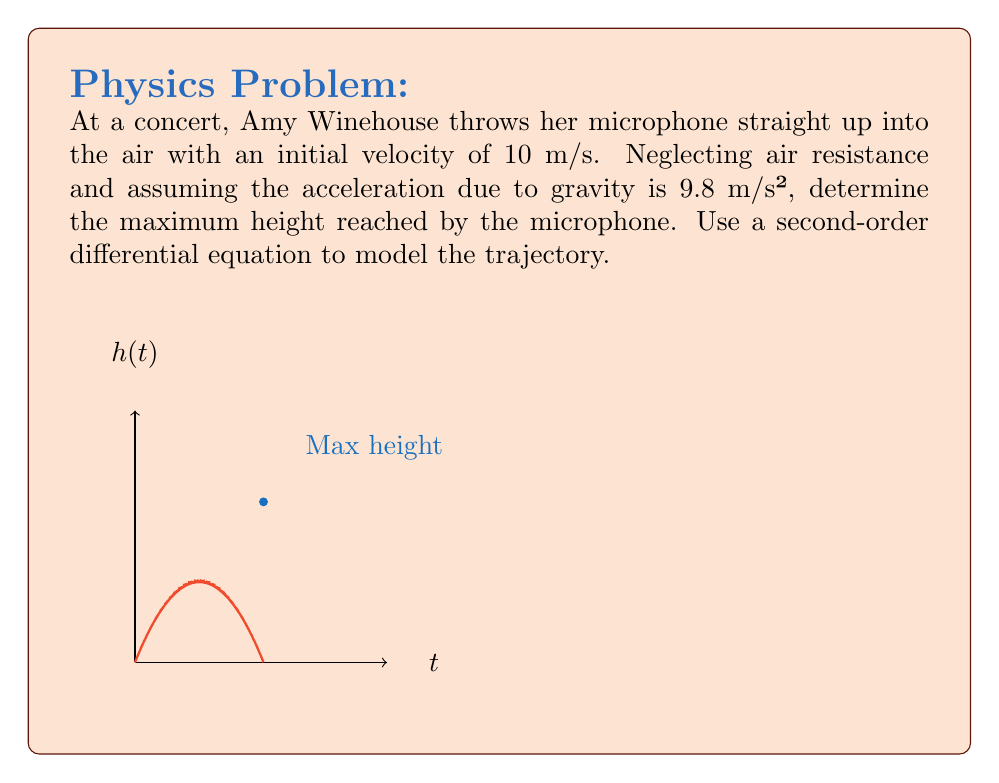Provide a solution to this math problem. Let's approach this step-by-step:

1) The motion of the microphone can be described by a second-order differential equation:

   $$\frac{d^2h}{dt^2} = -g$$

   where $h$ is the height, $t$ is time, and $g$ is the acceleration due to gravity (9.8 m/s²).

2) We can integrate this equation twice to get the position function:

   $$\frac{dh}{dt} = -gt + C_1$$
   $$h(t) = -\frac{1}{2}gt^2 + C_1t + C_2$$

3) We know the initial conditions:
   - At $t=0$, $h(0) = 0$ (starts at ground level)
   - At $t=0$, $\frac{dh}{dt}(0) = 10$ m/s (initial velocity)

4) Using these conditions:
   
   $$0 = C_2$$
   $$10 = C_1$$

5) So our height function is:

   $$h(t) = -4.9t^2 + 10t$$

6) To find the maximum height, we need to find when the velocity is zero:

   $$\frac{dh}{dt} = -9.8t + 10 = 0$$
   $$t = \frac{10}{9.8} \approx 1.02\text{ seconds}$$

7) Plugging this time back into our height function:

   $$h(1.02) = -4.9(1.02)^2 + 10(1.02) \approx 5.1\text{ meters}$$

Thus, the maximum height reached by the microphone is approximately 5.1 meters.
Answer: 5.1 meters 